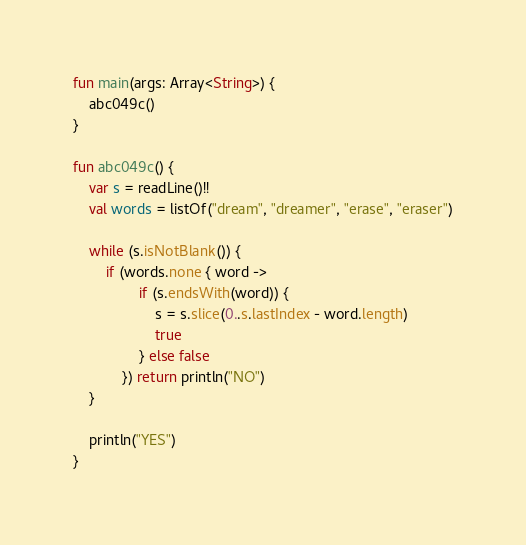<code> <loc_0><loc_0><loc_500><loc_500><_Kotlin_>fun main(args: Array<String>) {
    abc049c()
}

fun abc049c() {
    var s = readLine()!!
    val words = listOf("dream", "dreamer", "erase", "eraser")

    while (s.isNotBlank()) {
        if (words.none { word ->
                if (s.endsWith(word)) {
                    s = s.slice(0..s.lastIndex - word.length)
                    true
                } else false
            }) return println("NO")
    }

    println("YES")
}
</code> 